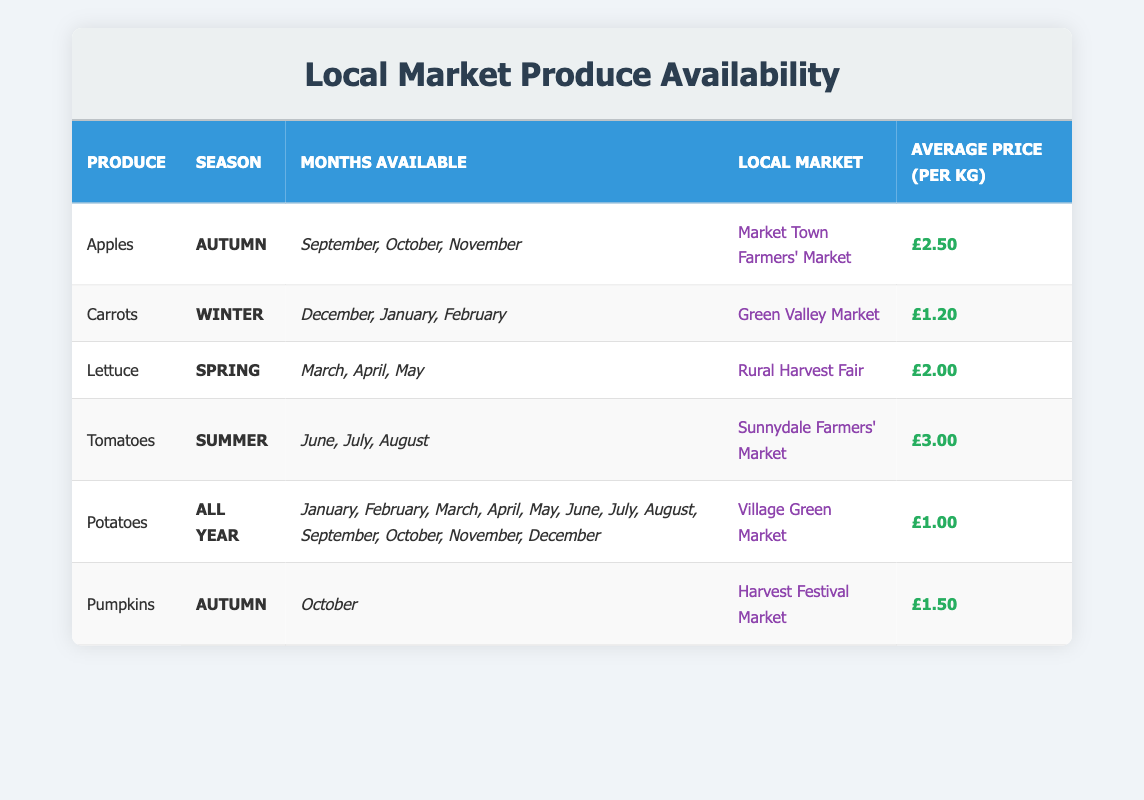What months are apples available in the local market? From the table, apples are available in September, October, and November, which are listed under the "Months Available" column for the produce "Apples" in the "Autumn" season.
Answer: September, October, November Which produce is the cheapest per kilogram? Looking at the "Average Price (per kg)" column, Potatoes are priced at £1.00 per kg, which is lower compared to other produce items listed in the table.
Answer: Potatoes Is lettuce available in the summer? The table specifies that lettuce is available in the Spring season, with the months listed as March, April, and May under the "Months Available" column. Therefore, lettuce is not available in the Summer.
Answer: No What is the average price of produce available in Autumn? The average price for produce available in Autumn includes apples (£2.50) and pumpkins (£1.50). To find the average: (2.50 + 1.50) / 2 = 2.00. Thus, the average price for Autumn produce is £2.00.
Answer: £2.00 Which local market sells tomatoes? The data shows that tomatoes are available at the "Sunnydale Farmers' Market," as specified in the "Local Market" column for "Tomatoes."
Answer: Sunnydale Farmers' Market How many types of produce are available all year round? From the table, only potatoes are listed under the "All Year" season, which indicates that they are available throughout the entire year.
Answer: 1 What is the combined average price of carrots and pumpkins? The average price for carrots is £1.20, and for pumpkins, it is £1.50. To find the combined average price: (1.20 + 1.50) / 2 = 1.35. Therefore, the combined average price of carrots and pumpkins is £1.35.
Answer: £1.35 Which produce has the highest price per kilogram? Checking the "Average Price (per kg)" column, tomatoes have the highest price at £3.00 per kg, compared to all other produce listed in the table.
Answer: Tomatoes 